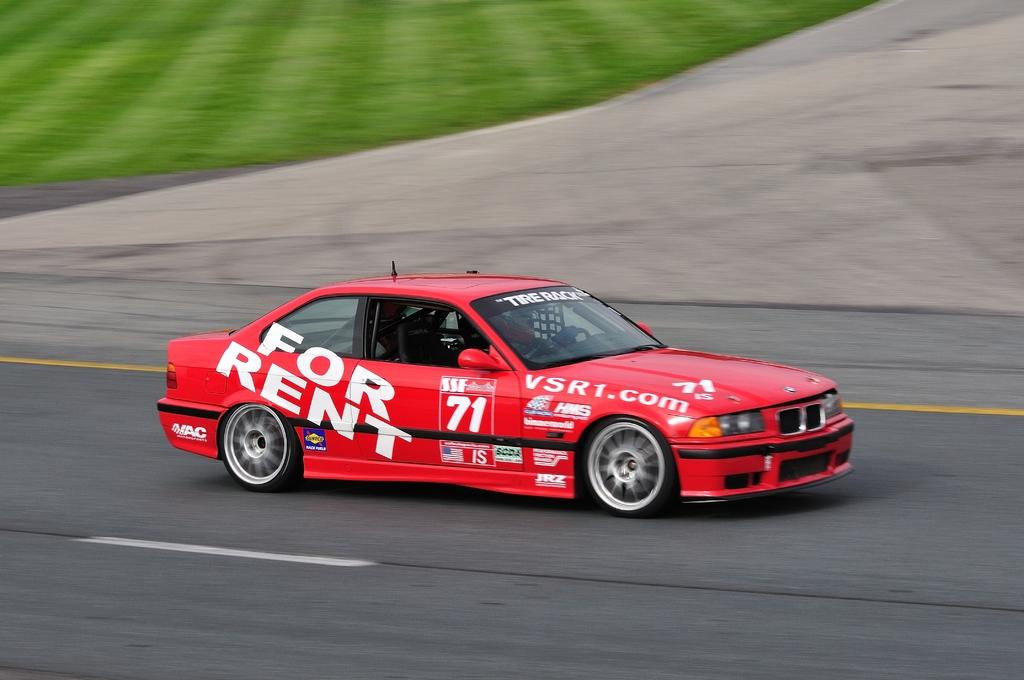What is the main subject in the center of the image? There is a car in the center of the image. What is located at the bottom of the image? There is a road at the bottom of the image. What type of natural environment can be seen in the background of the image? There is grass visible in the background of the image. What type of smell can be detected in the image? There is no information about smells in the image, so it cannot be determined from the image. 